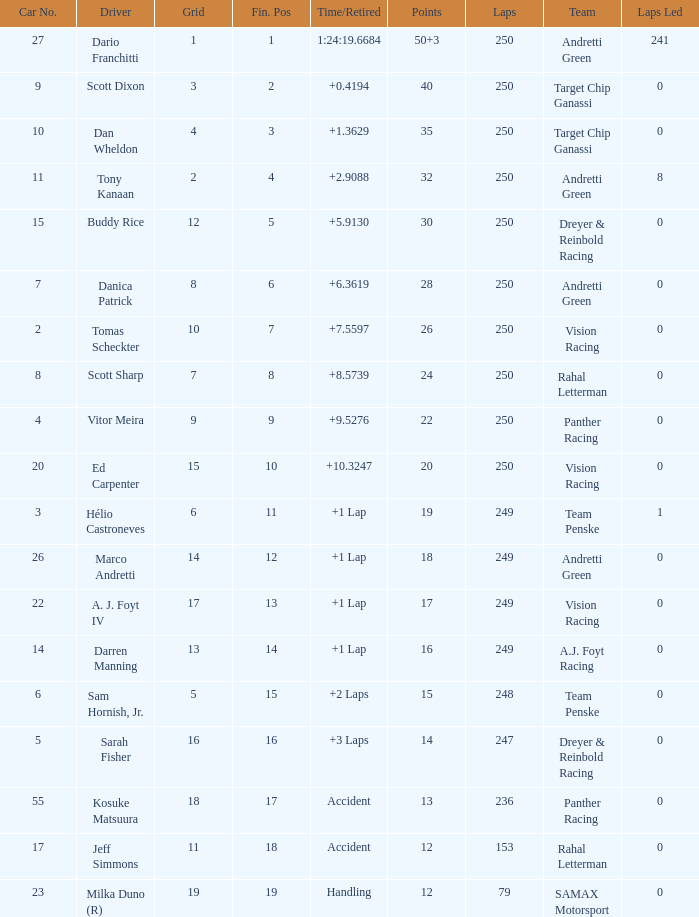Name the total number of fin pos for 12 points of accident 1.0. 